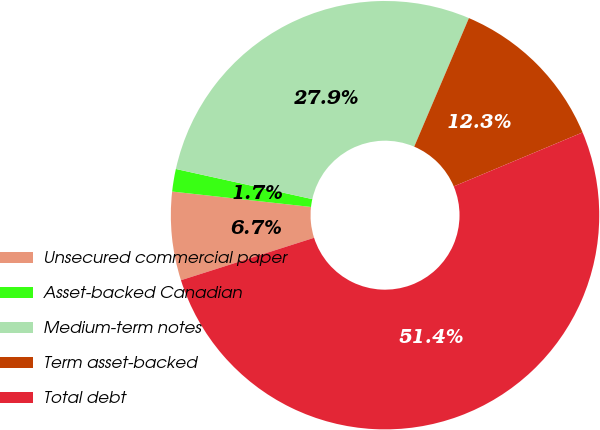Convert chart. <chart><loc_0><loc_0><loc_500><loc_500><pie_chart><fcel>Unsecured commercial paper<fcel>Asset-backed Canadian<fcel>Medium-term notes<fcel>Term asset-backed<fcel>Total debt<nl><fcel>6.67%<fcel>1.7%<fcel>27.94%<fcel>12.28%<fcel>51.4%<nl></chart> 